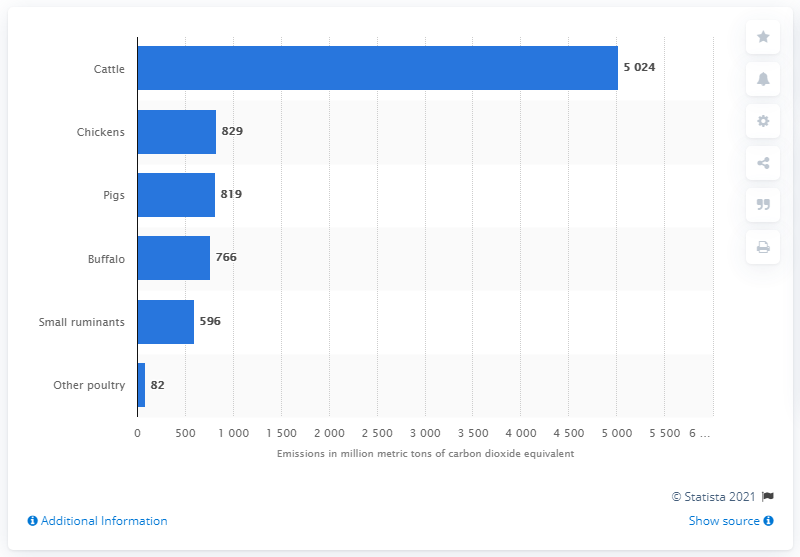Draw attention to some important aspects in this diagram. According to data from 2017, pigs emitted approximately 819 metric tons of carbon dioxide equivalent. According to a study, a significant portion of emissions from the livestock sector are attributed to pigs, poultry, buffaloes, and small ruminants. 